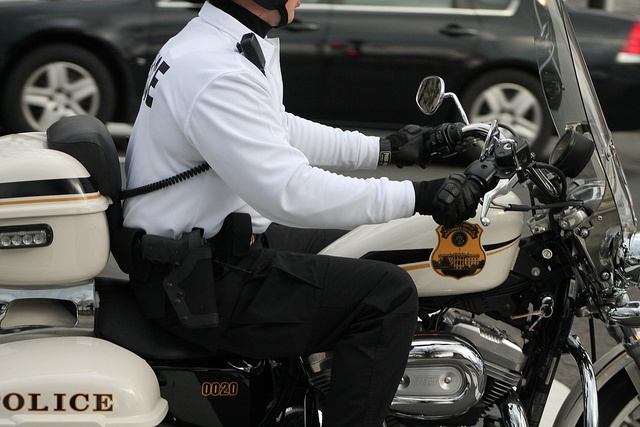Describe the objects in this image and their specific colors. I can see motorcycle in darkgray, black, gray, and lightgray tones, people in darkgray, black, and lightgray tones, and car in darkgray, black, and gray tones in this image. 